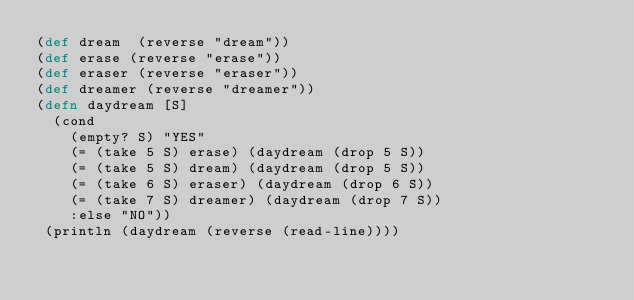Convert code to text. <code><loc_0><loc_0><loc_500><loc_500><_Clojure_>(def dream  (reverse "dream"))
(def erase (reverse "erase"))
(def eraser (reverse "eraser"))
(def dreamer (reverse "dreamer"))
(defn daydream [S]
  (cond
    (empty? S) "YES"
    (= (take 5 S) erase) (daydream (drop 5 S))
    (= (take 5 S) dream) (daydream (drop 5 S))
    (= (take 6 S) eraser) (daydream (drop 6 S))
    (= (take 7 S) dreamer) (daydream (drop 7 S))
    :else "NO"))
 (println (daydream (reverse (read-line))))</code> 